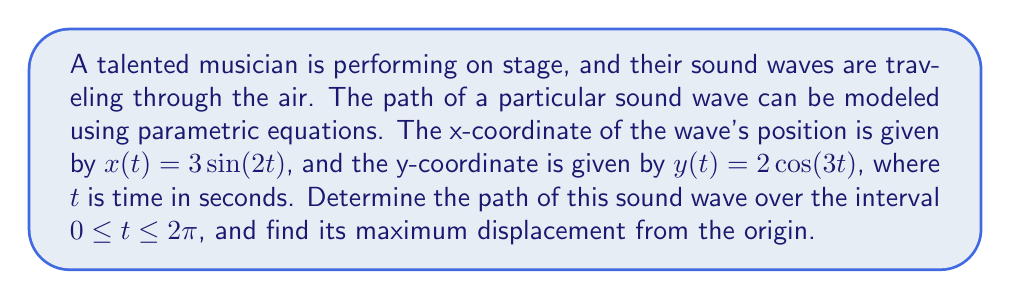Teach me how to tackle this problem. To determine the path of the sound wave and find its maximum displacement, we'll follow these steps:

1) The parametric equations describing the path are:
   $x(t) = 3\sin(2t)$
   $y(t) = 2\cos(3t)$

2) These equations trace out a curve called a Lissajous figure over the given interval $0 \leq t \leq 2\pi$.

3) To visualize this path, we can plot these equations:

[asy]
import graph;
size(200);
real x(real t) {return 3*sin(2t);}
real y(real t) {return 2*cos(3t);}
path p=graph(x,y,0,2pi,300);
draw(p,blue);
xaxis("x",-3.5,3.5,Arrow);
yaxis("y",-2.5,2.5,Arrow);
label("O",(0,0),SW);
[/asy]

4) To find the maximum displacement from the origin, we need to find the maximum possible distance from (0,0) to any point on the curve.

5) The distance from the origin to any point (x,y) is given by $\sqrt{x^2 + y^2}$.

6) Substituting our parametric equations:

   $d(t) = \sqrt{(3\sin(2t))^2 + (2\cos(3t))^2}$
   
   $d(t) = \sqrt{9\sin^2(2t) + 4\cos^2(3t)}$

7) The maximum value of this function will be the maximum displacement.

8) We know that $\sin^2(2t) \leq 1$ and $\cos^2(3t) \leq 1$ for all $t$.

9) Therefore, the maximum possible value of $d(t)$ occurs when both $\sin^2(2t) = 1$ and $\cos^2(3t) = 1$ simultaneously.

10) In this case:

    $d_{max} = \sqrt{9(1) + 4(1)} = \sqrt{13}$

Thus, the maximum displacement from the origin is $\sqrt{13}$ units.
Answer: The path of the sound wave is a Lissajous figure, and its maximum displacement from the origin is $\sqrt{13}$ units. 